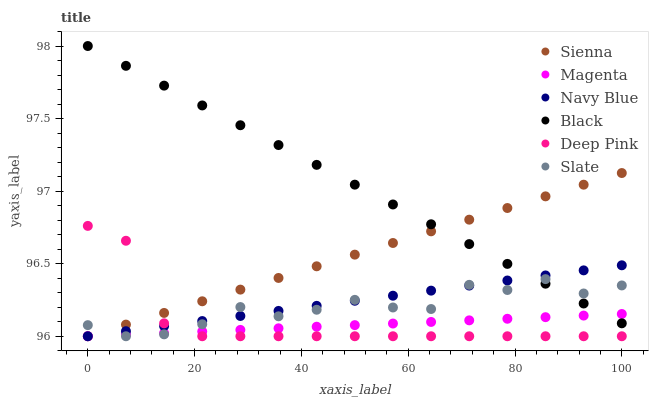Does Magenta have the minimum area under the curve?
Answer yes or no. Yes. Does Black have the maximum area under the curve?
Answer yes or no. Yes. Does Navy Blue have the minimum area under the curve?
Answer yes or no. No. Does Navy Blue have the maximum area under the curve?
Answer yes or no. No. Is Magenta the smoothest?
Answer yes or no. Yes. Is Slate the roughest?
Answer yes or no. Yes. Is Navy Blue the smoothest?
Answer yes or no. No. Is Navy Blue the roughest?
Answer yes or no. No. Does Deep Pink have the lowest value?
Answer yes or no. Yes. Does Black have the lowest value?
Answer yes or no. No. Does Black have the highest value?
Answer yes or no. Yes. Does Navy Blue have the highest value?
Answer yes or no. No. Is Deep Pink less than Black?
Answer yes or no. Yes. Is Black greater than Deep Pink?
Answer yes or no. Yes. Does Sienna intersect Slate?
Answer yes or no. Yes. Is Sienna less than Slate?
Answer yes or no. No. Is Sienna greater than Slate?
Answer yes or no. No. Does Deep Pink intersect Black?
Answer yes or no. No. 